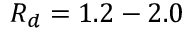Convert formula to latex. <formula><loc_0><loc_0><loc_500><loc_500>R _ { d } = 1 . 2 - 2 . 0</formula> 